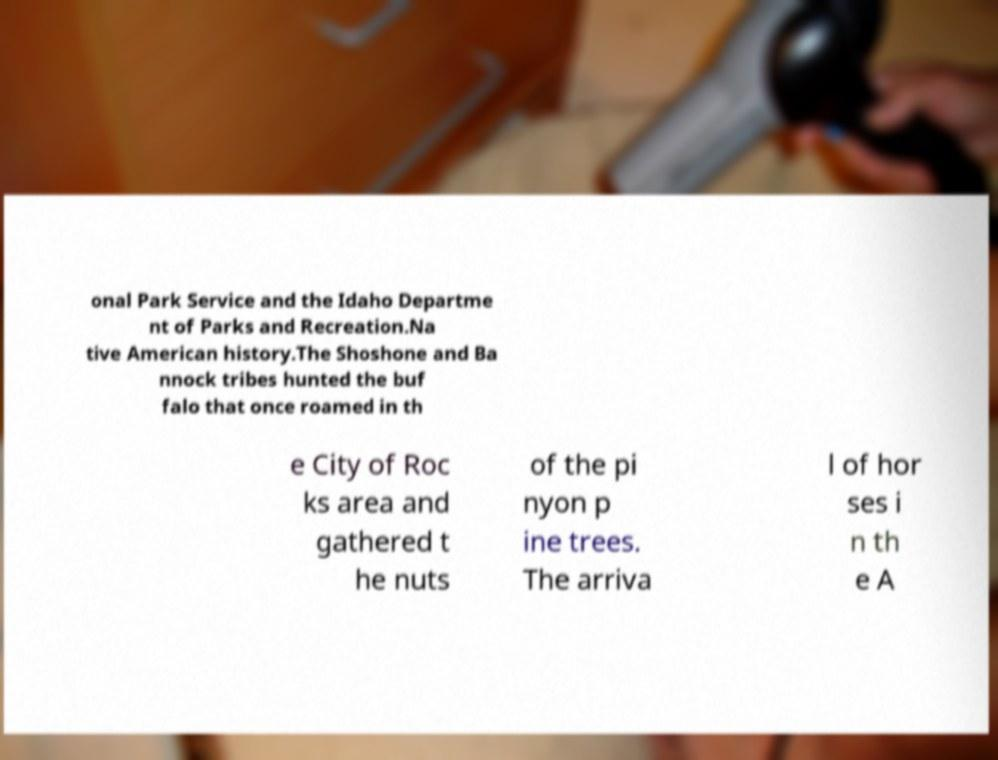Can you accurately transcribe the text from the provided image for me? onal Park Service and the Idaho Departme nt of Parks and Recreation.Na tive American history.The Shoshone and Ba nnock tribes hunted the buf falo that once roamed in th e City of Roc ks area and gathered t he nuts of the pi nyon p ine trees. The arriva l of hor ses i n th e A 